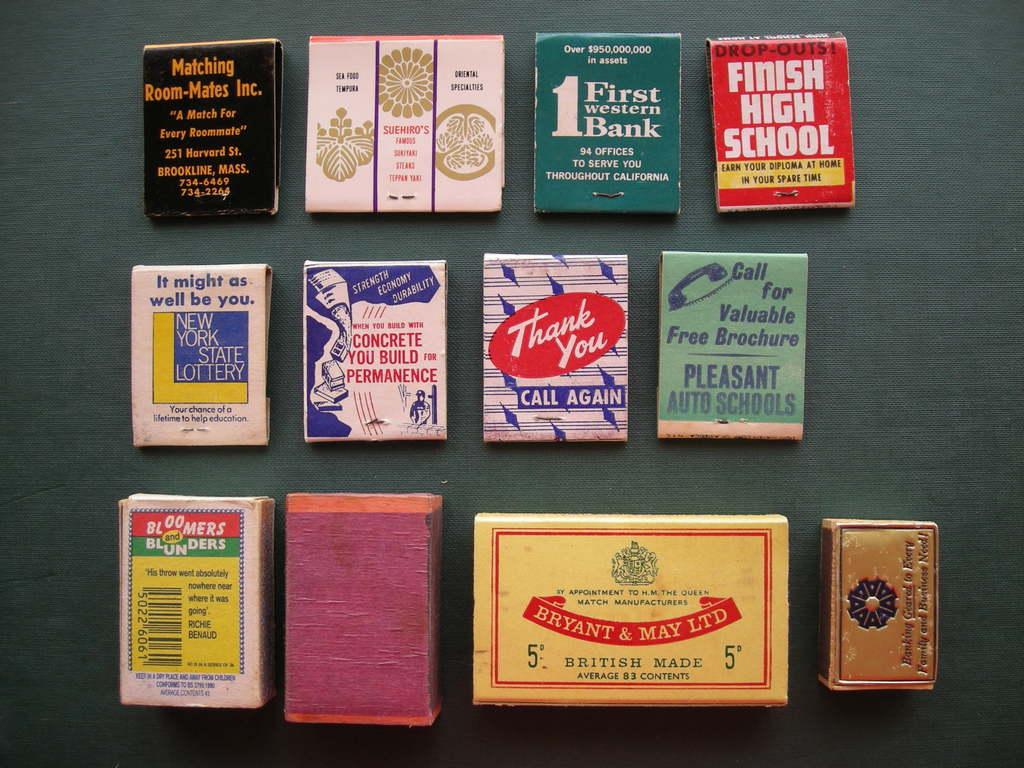How many books is there?
Your answer should be compact. Answering does not require reading text in the image. How many rows of match books are there?
Keep it short and to the point. Answering does not require reading text in the image. 